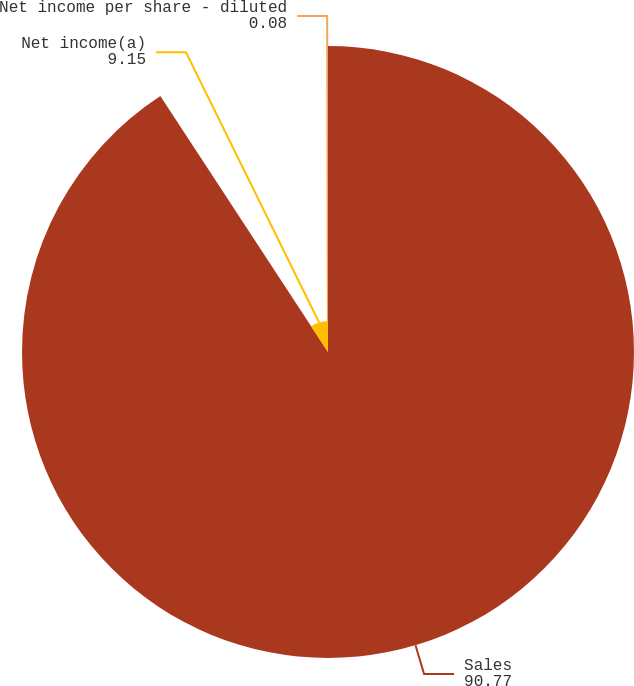Convert chart. <chart><loc_0><loc_0><loc_500><loc_500><pie_chart><fcel>Sales<fcel>Net income(a)<fcel>Net income per share - diluted<nl><fcel>90.77%<fcel>9.15%<fcel>0.08%<nl></chart> 